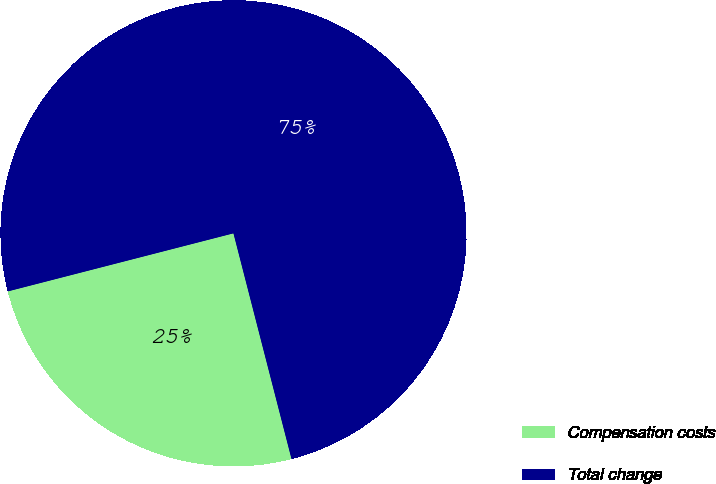Convert chart to OTSL. <chart><loc_0><loc_0><loc_500><loc_500><pie_chart><fcel>Compensation costs<fcel>Total change<nl><fcel>25.0%<fcel>75.0%<nl></chart> 